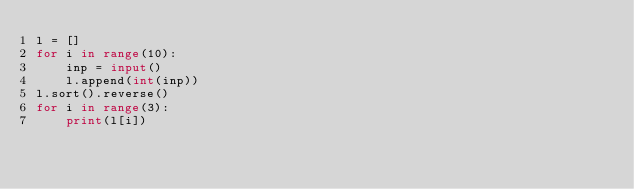<code> <loc_0><loc_0><loc_500><loc_500><_Python_>l = []
for i in range(10):
    inp = input()
    l.append(int(inp))
l.sort().reverse()
for i in range(3):
    print(l[i])</code> 